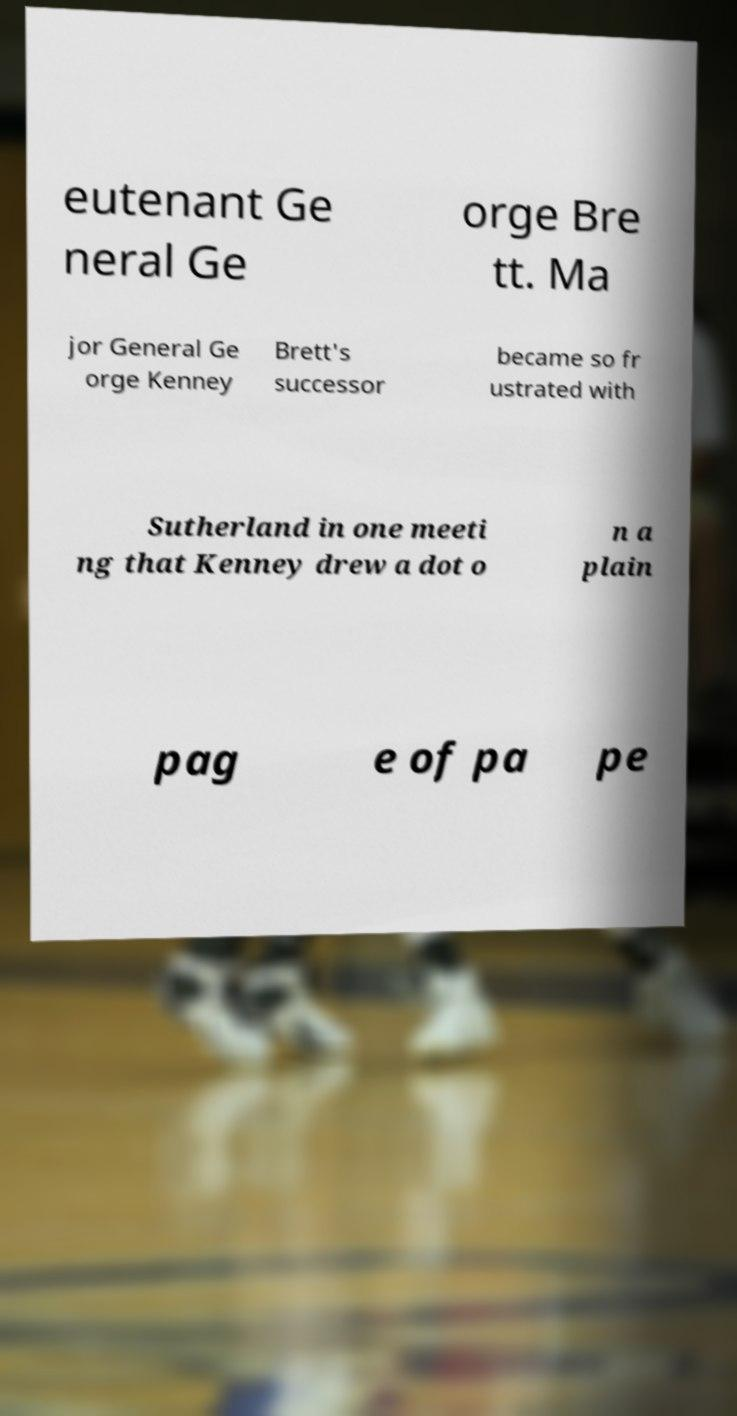Please identify and transcribe the text found in this image. eutenant Ge neral Ge orge Bre tt. Ma jor General Ge orge Kenney Brett's successor became so fr ustrated with Sutherland in one meeti ng that Kenney drew a dot o n a plain pag e of pa pe 